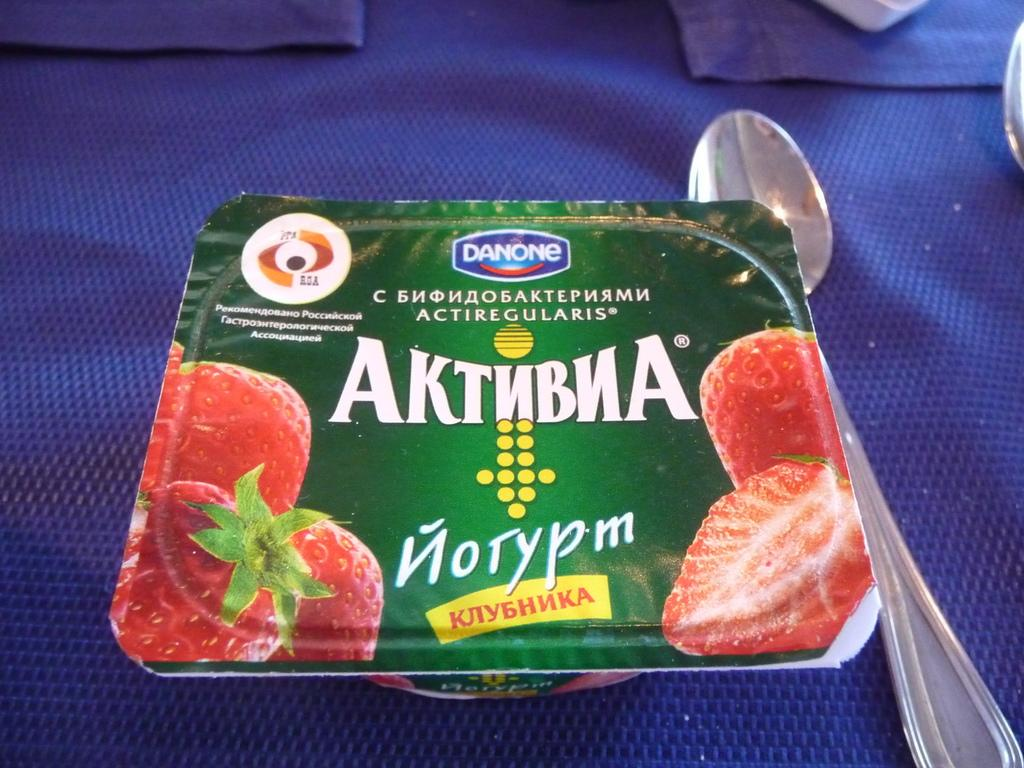What is depicted on the box in the image? There is a box with text and fruit images in the image. What utensil can be seen in the image? There is a spoon in the image. Where is the spoon placed in the image? The spoon is on a cloth in the image. What type of pies are being sold in the image? There are no pies present in the image; it features a box with fruit images and a spoon on a cloth. 